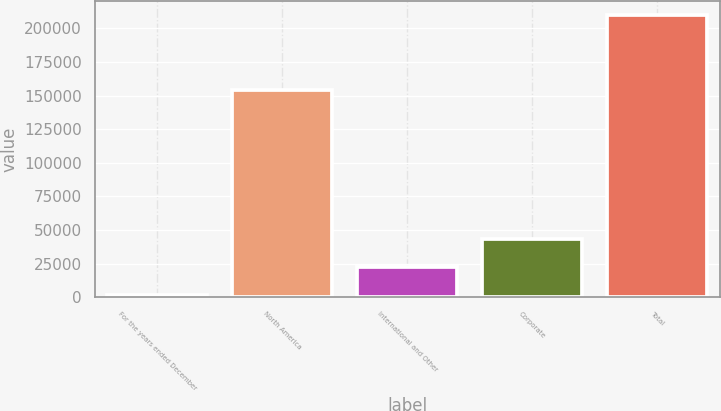<chart> <loc_0><loc_0><loc_500><loc_500><bar_chart><fcel>For the years ended December<fcel>North America<fcel>International and Other<fcel>Corporate<fcel>Total<nl><fcel>2012<fcel>154348<fcel>22814.5<fcel>43617<fcel>210037<nl></chart> 